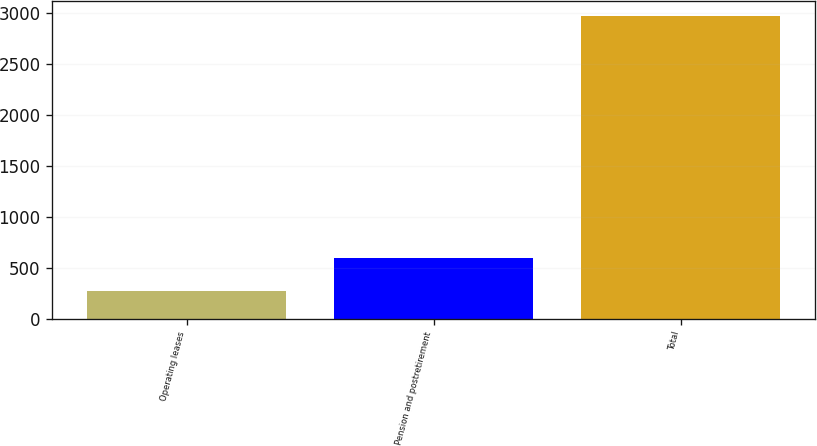<chart> <loc_0><loc_0><loc_500><loc_500><bar_chart><fcel>Operating leases<fcel>Pension and postretirement<fcel>Total<nl><fcel>273.2<fcel>601.4<fcel>2962.7<nl></chart> 